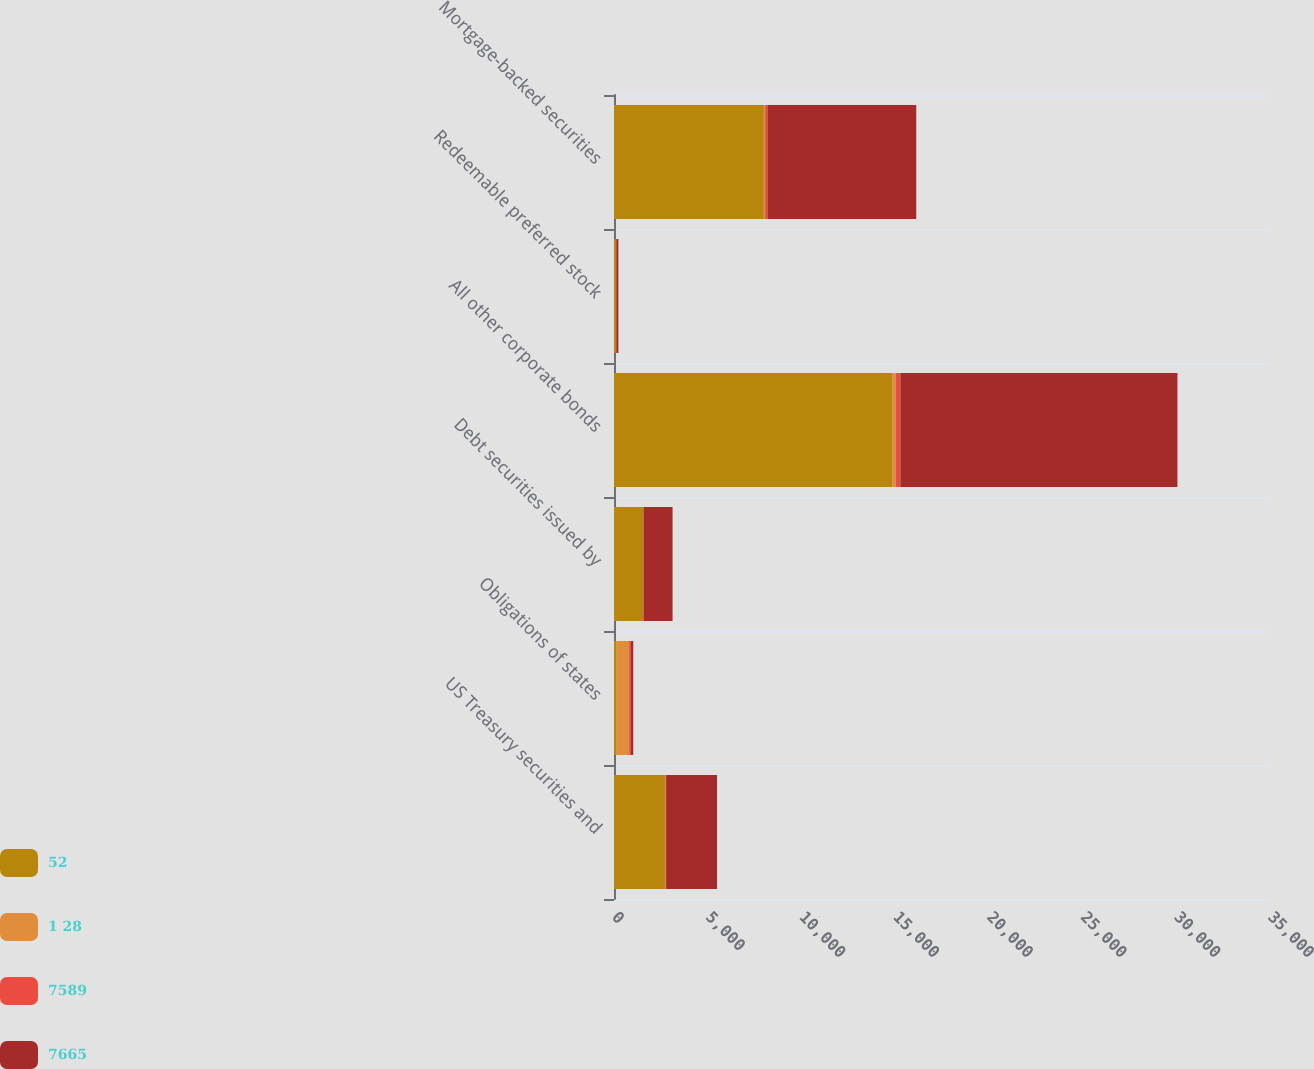Convert chart to OTSL. <chart><loc_0><loc_0><loc_500><loc_500><stacked_bar_chart><ecel><fcel>US Treasury securities and<fcel>Obligations of states<fcel>Debt securities issued by<fcel>All other corporate bonds<fcel>Redeemable preferred stock<fcel>Mortgage-backed securities<nl><fcel>52<fcel>2736<fcel>143<fcel>1550<fcel>14866<fcel>101<fcel>7997<nl><fcel>1 28<fcel>13<fcel>661<fcel>12<fcel>165<fcel>16<fcel>66<nl><fcel>7589<fcel>31<fcel>80<fcel>10<fcel>247<fcel>1<fcel>121<nl><fcel>7665<fcel>2718<fcel>143<fcel>1552<fcel>14784<fcel>116<fcel>7942<nl></chart> 